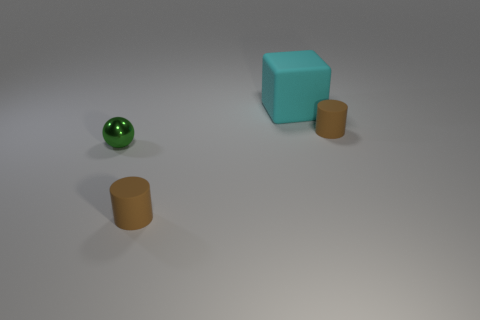Add 1 gray rubber blocks. How many objects exist? 5 Subtract all cubes. How many objects are left? 3 Add 4 tiny blue metal cylinders. How many tiny blue metal cylinders exist? 4 Subtract 0 blue cubes. How many objects are left? 4 Subtract all big cyan rubber objects. Subtract all big cyan rubber things. How many objects are left? 2 Add 3 small metal spheres. How many small metal spheres are left? 4 